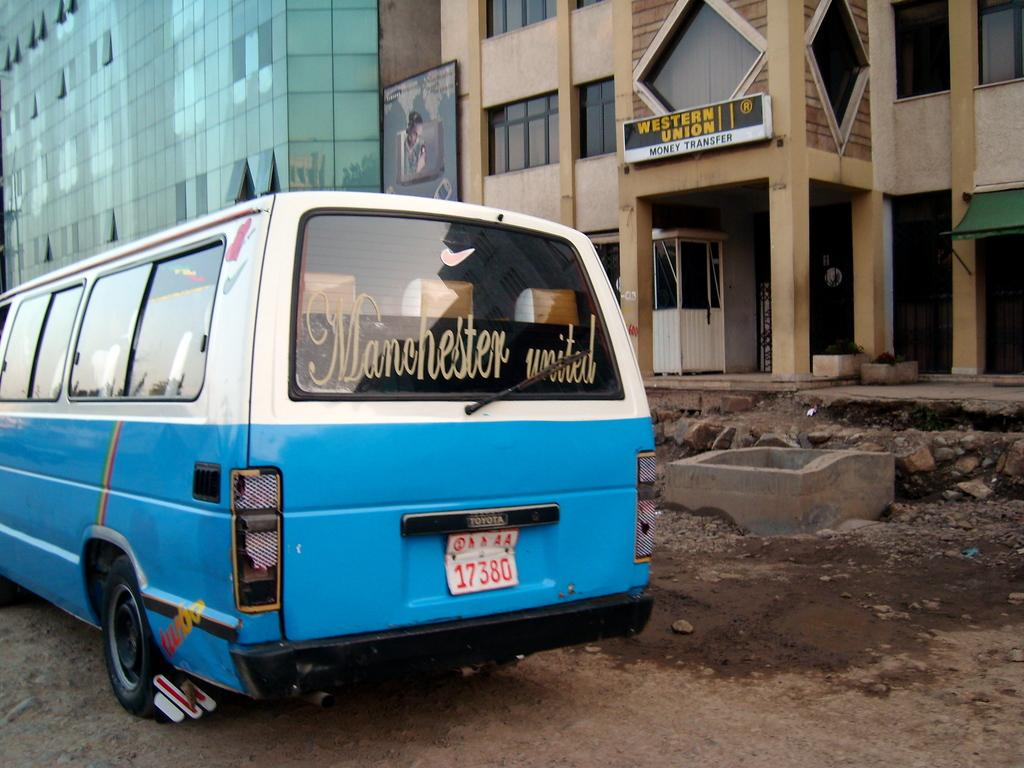What is the main subject of the image? There is a vehicle on the road in the image. What can be seen in the background of the image? There are buildings in the background of the image. Is there any text or signage visible in the image? Yes, there is a board with some text in the image. What type of boot is being used to measure the drug in the image? There is no boot, measuring device, or drug present in the image. 